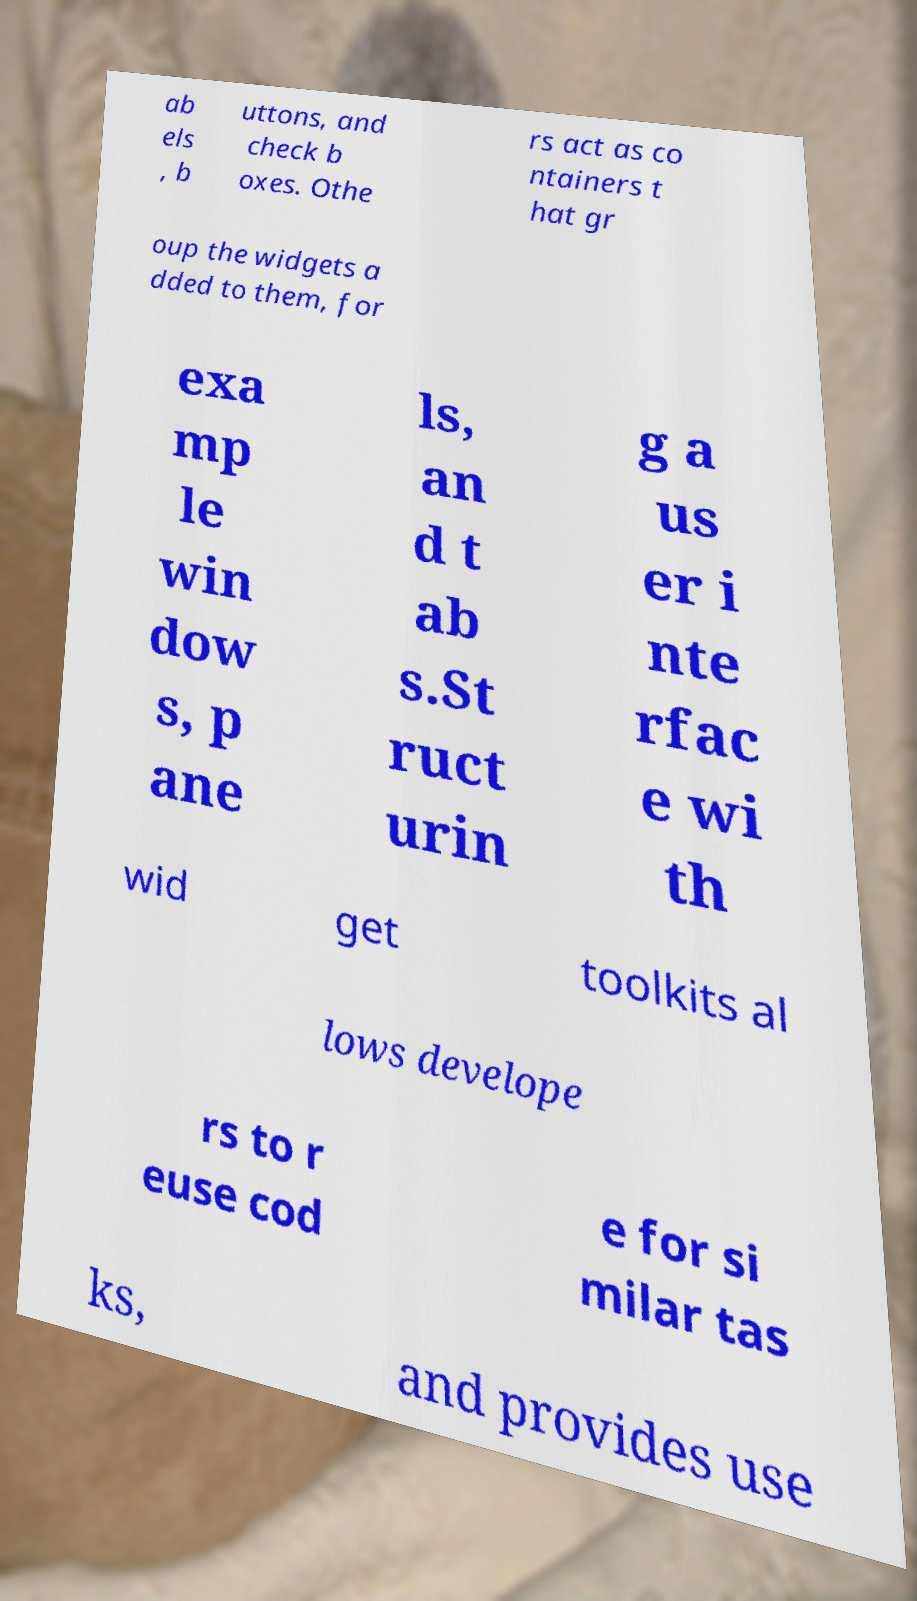Could you assist in decoding the text presented in this image and type it out clearly? ab els , b uttons, and check b oxes. Othe rs act as co ntainers t hat gr oup the widgets a dded to them, for exa mp le win dow s, p ane ls, an d t ab s.St ruct urin g a us er i nte rfac e wi th wid get toolkits al lows develope rs to r euse cod e for si milar tas ks, and provides use 